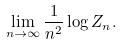Convert formula to latex. <formula><loc_0><loc_0><loc_500><loc_500>\lim _ { n \rightarrow \infty } \frac { 1 } { n ^ { 2 } } \log Z _ { n } .</formula> 